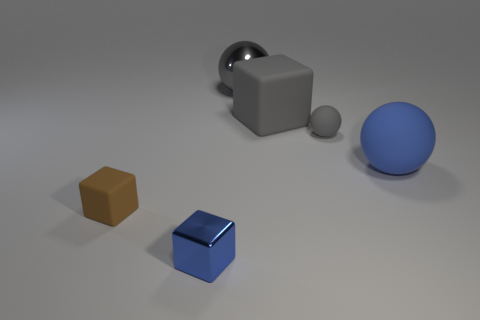Are there any objects that are right of the small ball that is to the right of the tiny thing that is left of the blue shiny cube?
Offer a very short reply. Yes. What shape is the large blue object that is the same material as the small brown thing?
Your answer should be compact. Sphere. The large blue object has what shape?
Keep it short and to the point. Sphere. There is a big gray thing that is behind the gray cube; is it the same shape as the tiny blue thing?
Your answer should be compact. No. Is the number of rubber spheres left of the large matte sphere greater than the number of big cubes that are on the right side of the gray block?
Provide a short and direct response. Yes. What number of other objects are there of the same size as the blue metallic object?
Give a very brief answer. 2. There is a blue rubber object; is it the same shape as the shiny object behind the blue matte ball?
Your response must be concise. Yes. How many metal things are either blue balls or small red cylinders?
Your answer should be compact. 0. Are there any things of the same color as the big metal ball?
Offer a terse response. Yes. Are there any gray rubber objects?
Your answer should be very brief. Yes. 